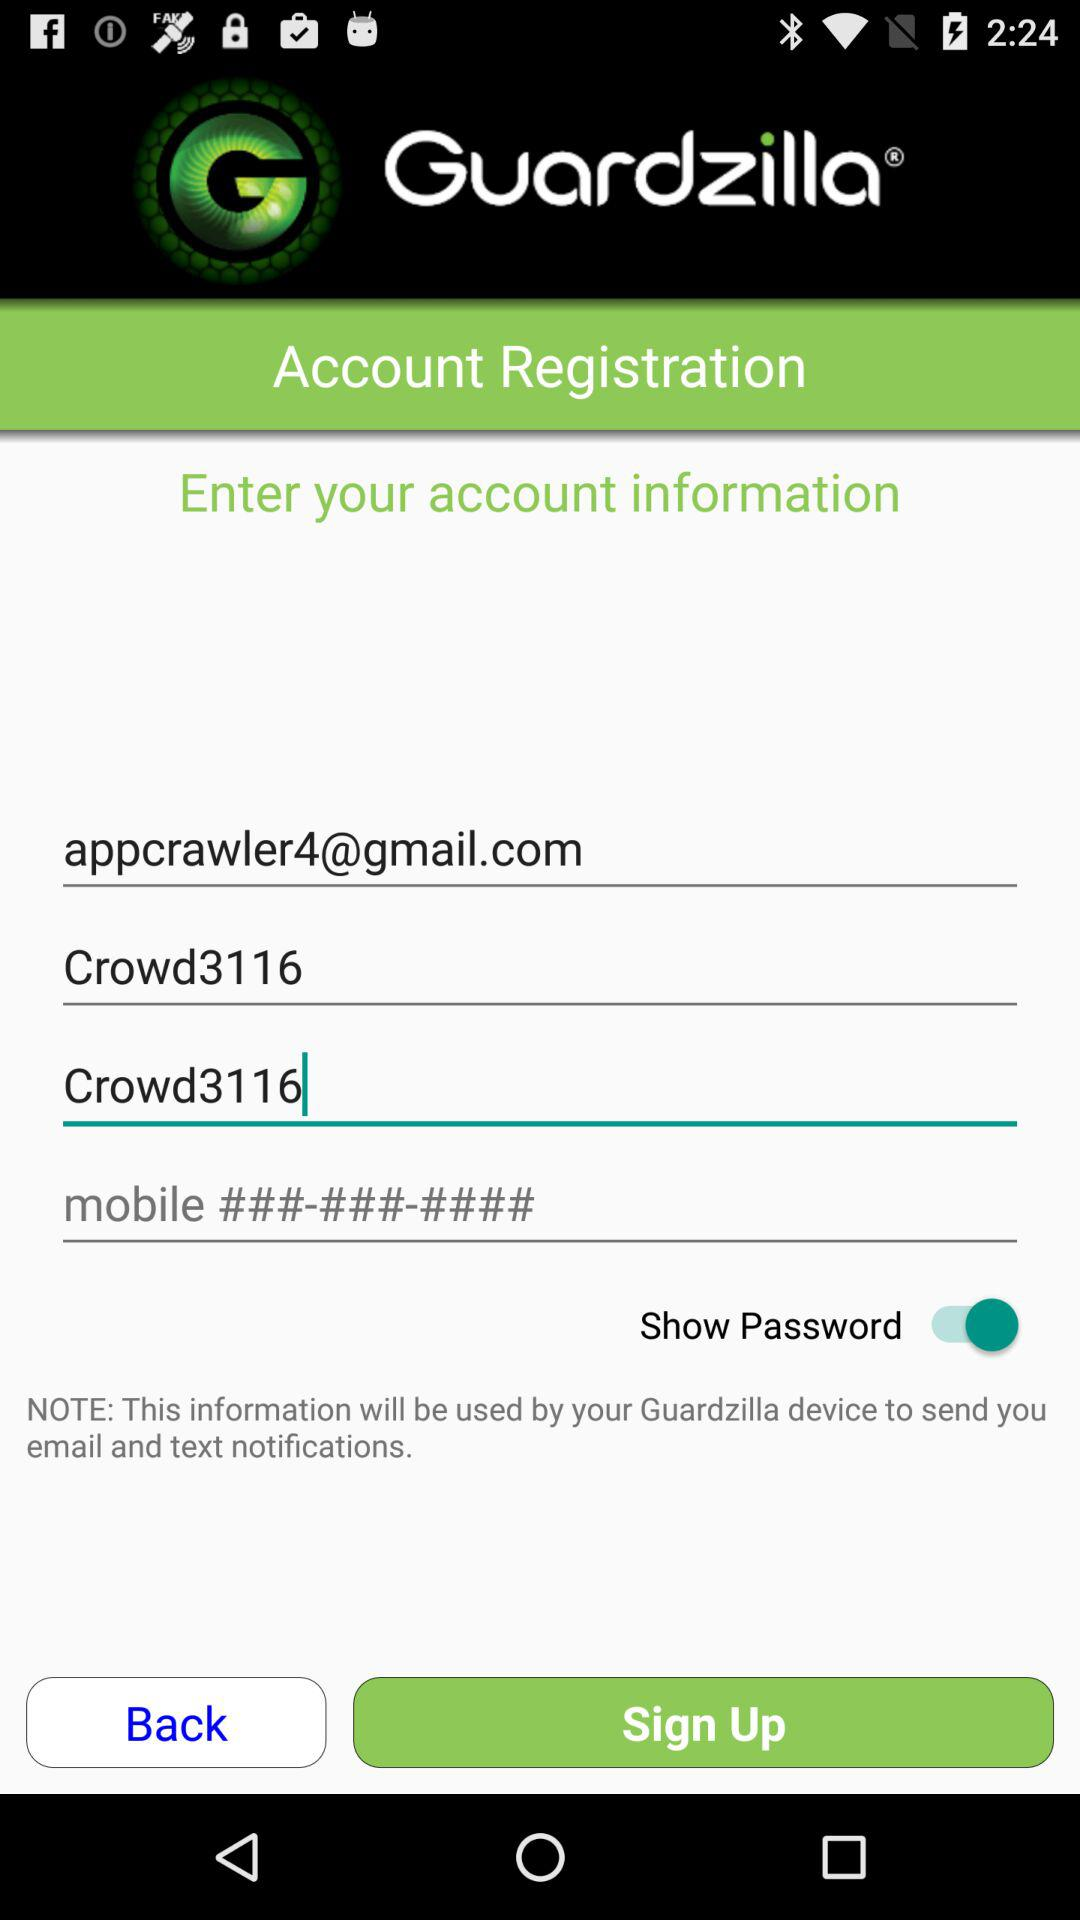What is the email address? The email address is "appcrawler4@gmail.com". 